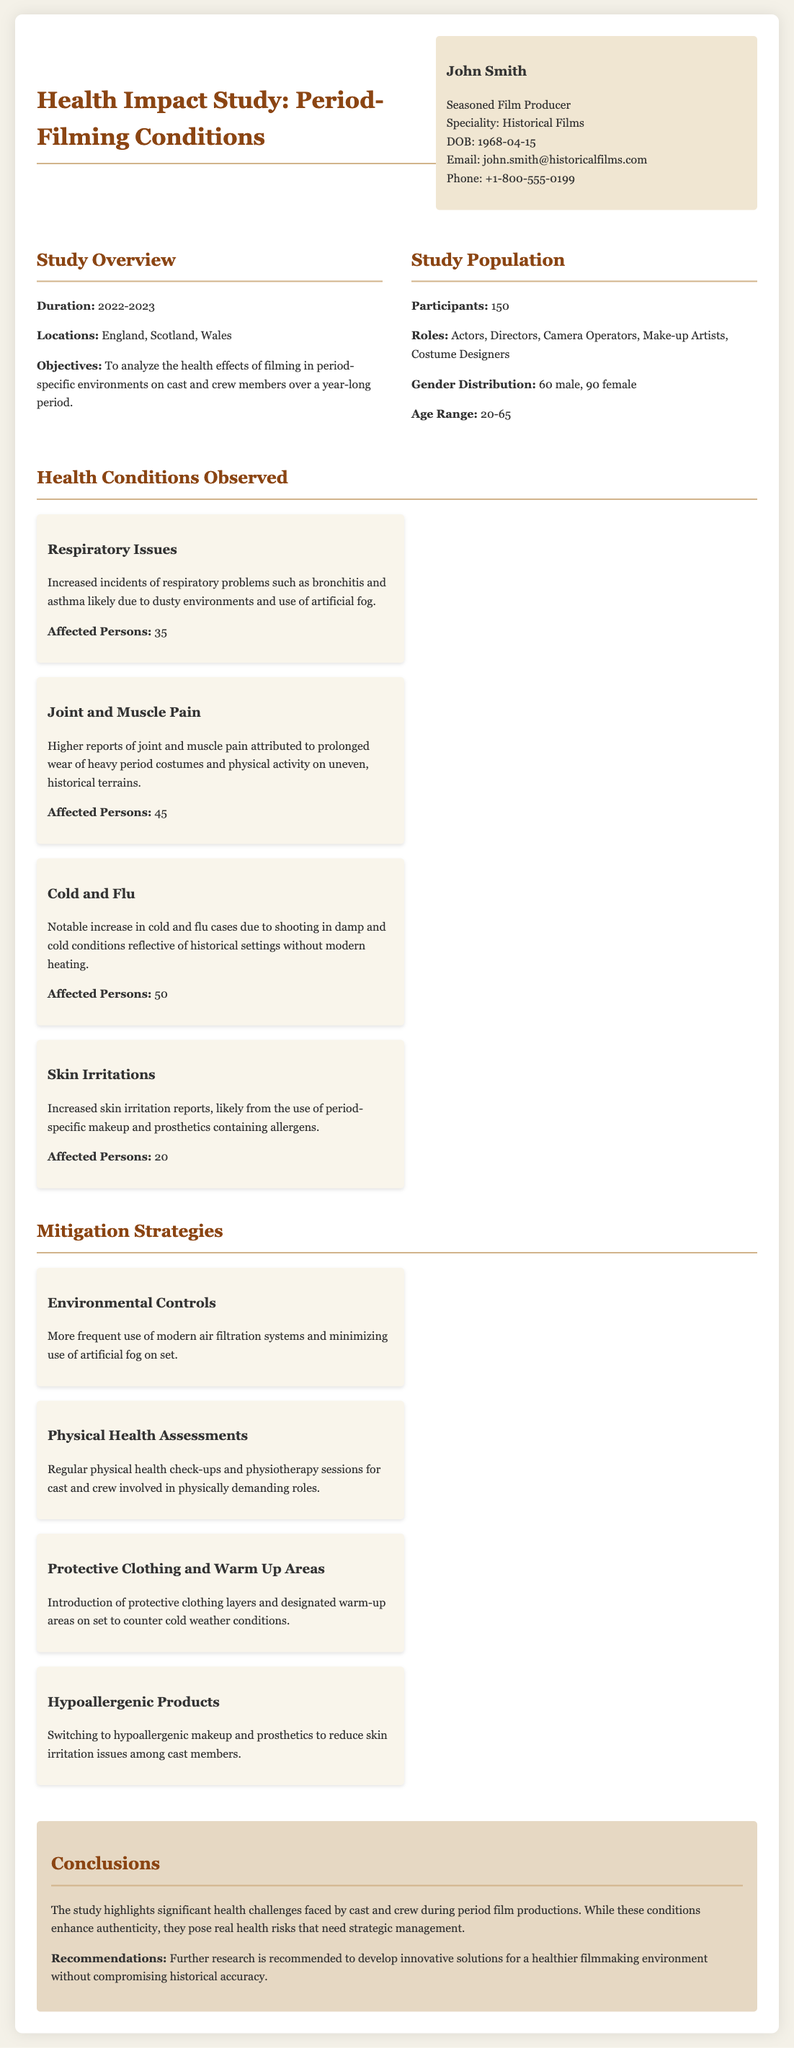What is the study duration? The study duration is specified as a year-long period from 2022 to 2023.
Answer: 2022-2023 How many participants were involved in the study? The document states that there were 150 participants involved in the study.
Answer: 150 What health condition had the highest number of affected persons? By reviewing the health conditions listed, the one with the highest number of affected persons is cold and flu, which had 50 affected individuals.
Answer: Cold and Flu What locations were included in the study? The document outlines that the study took place in England, Scotland, and Wales.
Answer: England, Scotland, Wales What mitigation strategy involves modern technology? The strategy that mentions the use of modern technology is "Environmental Controls" which includes air filtration systems.
Answer: Environmental Controls How many male participants were there? The document specifies the gender distribution showing there were 60 male participants.
Answer: 60 What type of environments contributed to respiratory issues? The document notes that dusty environments and the use of artificial fog contributed to respiratory issues.
Answer: Dusty environments What is one recommendation made in the conclusions? The conclusion section summarizes that further research is recommended to develop solutions for a healthier filming environment.
Answer: Further research Which strategy addresses skin irritation? The strategy that addresses skin irritation specifies using hypoallergenic products for makeup and prosthetics.
Answer: Hypoallergenic Products 